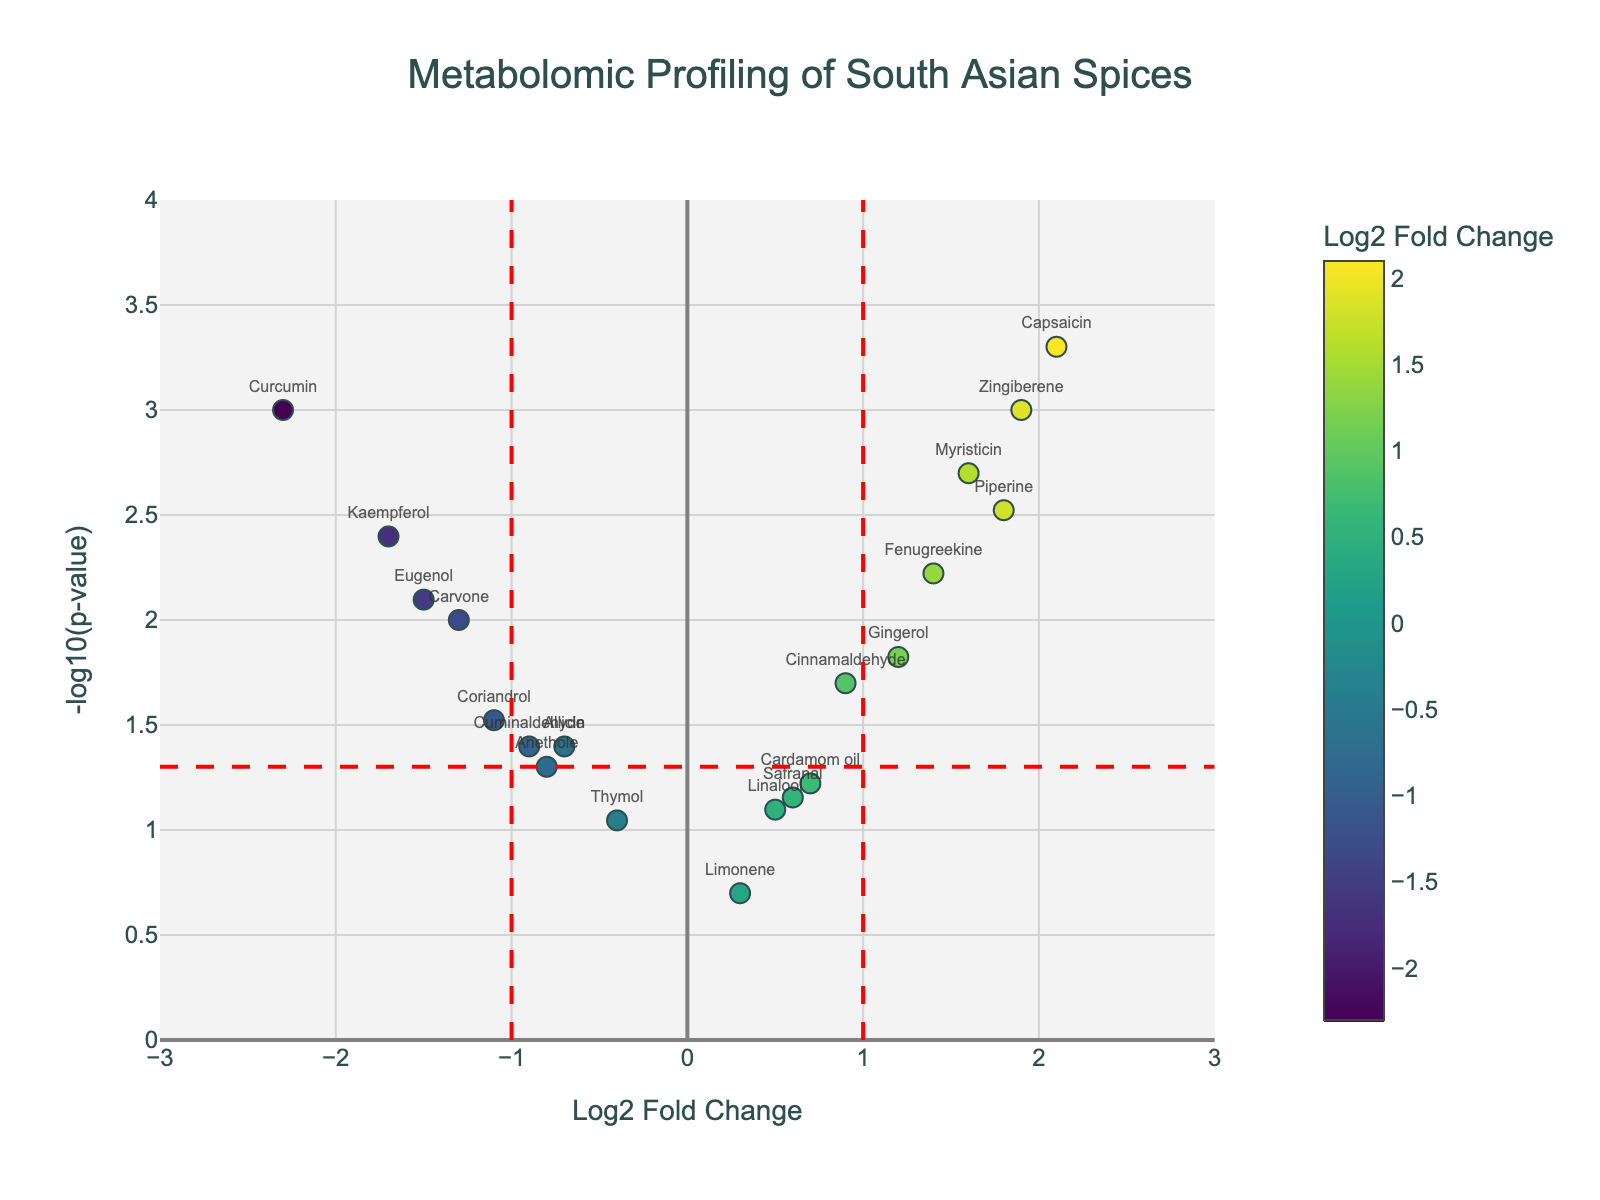What is the title of the figure? The title of the figure is presented at the top and is clearly labeled for easy identification.
Answer: Metabolomic Profiling of South Asian Spices What do the x-axis and y-axis represent? The x-axis is labeled "Log2 Fold Change," and the y-axis is labeled "-log10(p-value)."
Answer: Log2 Fold Change and -log10(p-value) How many compounds have a p-value less than 0.05? To determine this, locate the compounds above the horizontal red dashed line, which represents the significance threshold (-log10(0.05)). Count these compounds.
Answer: 12 Which compound has the highest positive Log2 Fold Change? The highest positive Log2 Fold Change is found by looking for the rightmost point on the x-axis.
Answer: Capsaicin Which compound has the lowest Log2 Fold Change? The lowest Log2 Fold Change is found by looking for the leftmost point on the x-axis.
Answer: Curcumin Are there any compounds with both a high p-value and a low Log2 Fold Change? This requires identifying compounds near the horizontal red dashed line (p-value around 0.05, or -log10(p-value) close to 1.3) and closer to the center (Log2 Fold Change near 0).
Answer: Thymol and Limonene Which compound has the highest -log10(p-value)? Identify the compound with the highest point on the y-axis, which corresponds to the lowest p-value.
Answer: Capsaicin How many compounds have a negative Log2 Fold Change? Look for compounds located left of the vertical dashed line at Log2 Fold Change = 0 and count them.
Answer: 8 Compare Eugenol and Cardamom oil based on their Log2 Fold Changes and p-values. Eugenol has a negative Log2 Fold Change (-1.5) and a p-value of 0.008, while Cardamom oil has a positive Log2 Fold Change (0.7) with a p-value of 0.06. So, Eugenol has lower Log2 Fold Change and a lower p-value compared to Cardamom oil.
Answer: Eugenol has a lower Log2 Fold Change and a lower p-value than Cardamom oil 